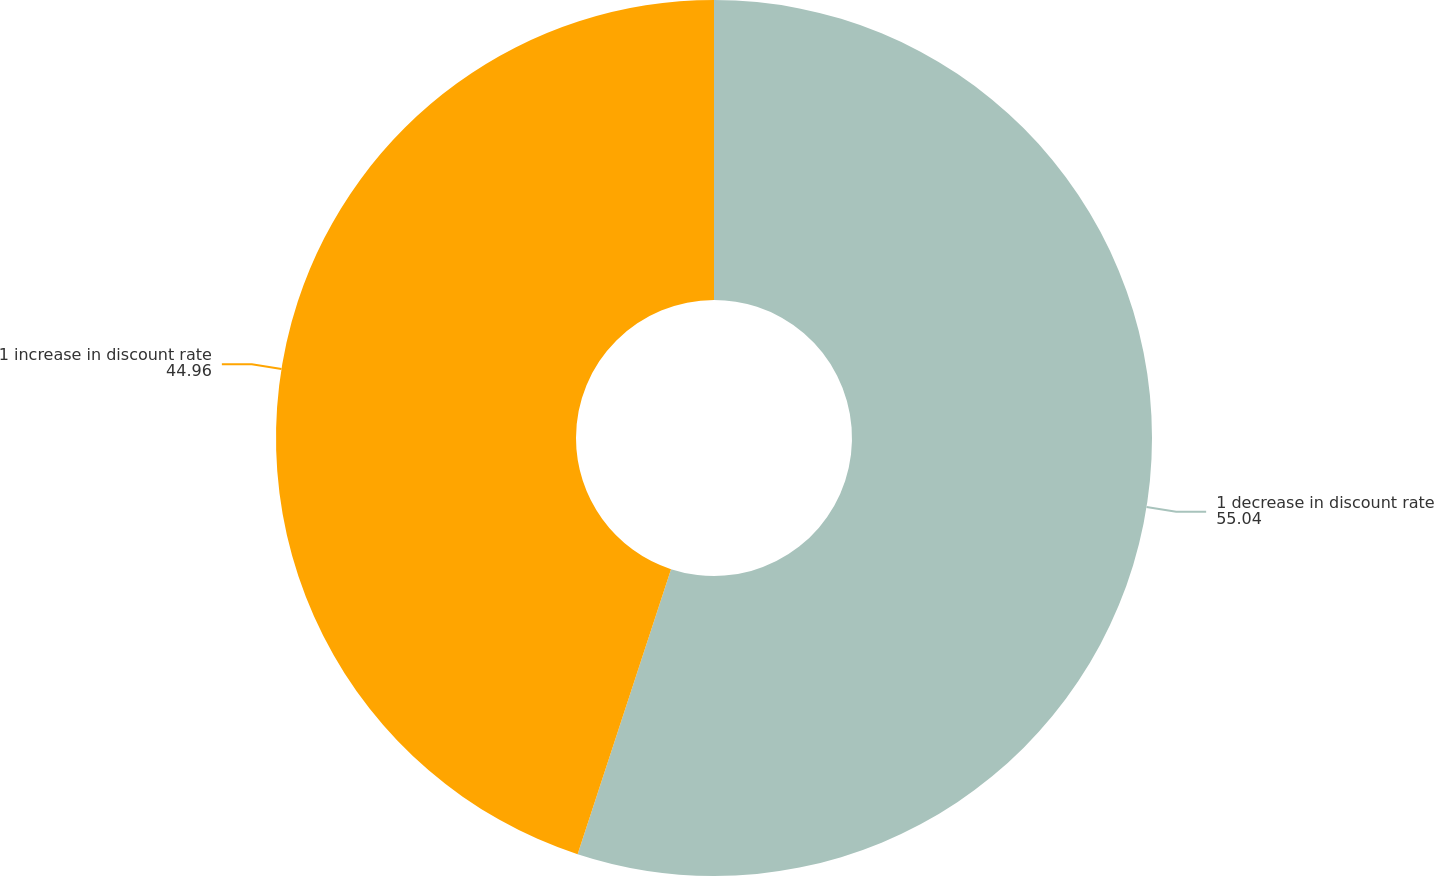Convert chart. <chart><loc_0><loc_0><loc_500><loc_500><pie_chart><fcel>1 decrease in discount rate<fcel>1 increase in discount rate<nl><fcel>55.04%<fcel>44.96%<nl></chart> 